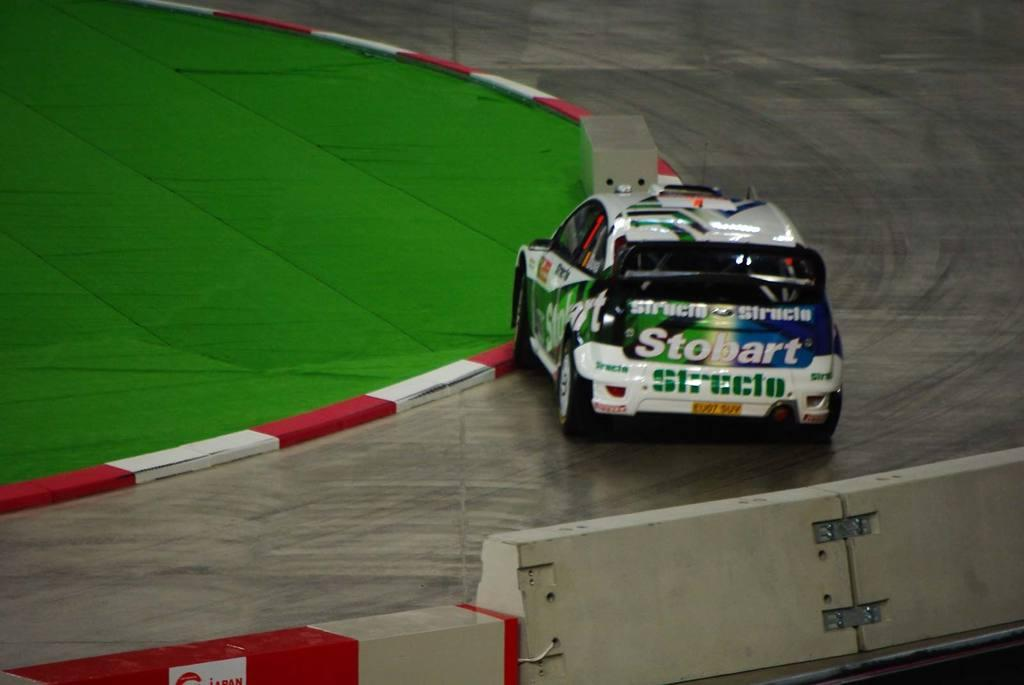What is the main subject in the foreground of the image? There is a car on the road in the foreground of the image. What is present at the bottom of the image? There is a boundary at the bottom of the image. What type of vegetation can be seen on the left side of the image? There is grassy land on the left side of the image. What type of vest is the car wearing in the image? Cars do not wear vests, as they are inanimate objects. --- Facts: 1. There is a person holding a book in the image. 2. The person is sitting on a chair. 3. There is a table in front of the person. 4. The table has a lamp on it. Absurd Topics: elephant, ocean, bicycle Conversation: What is the person in the image holding? The person is holding a book in the image. What is the person sitting on? The person is sitting on a chair. What object is in front of the person? There is a table in front of the person. What is on the table? The table has a lamp on it. Reasoning: Let's think step by step in order to produce the conversation. We start by identifying the main subject in the image, which is the person holding a book. Then, we describe the person's position, noting that they are sitting on a chair. Next, we mention the table in front of the person, which provides context for the scene. Finally, we describe the object on the table, which is a lamp. Absurd Question/Answer: Can you see an elephant swimming in the ocean in the image? No, there is no elephant or ocean present in the image. 